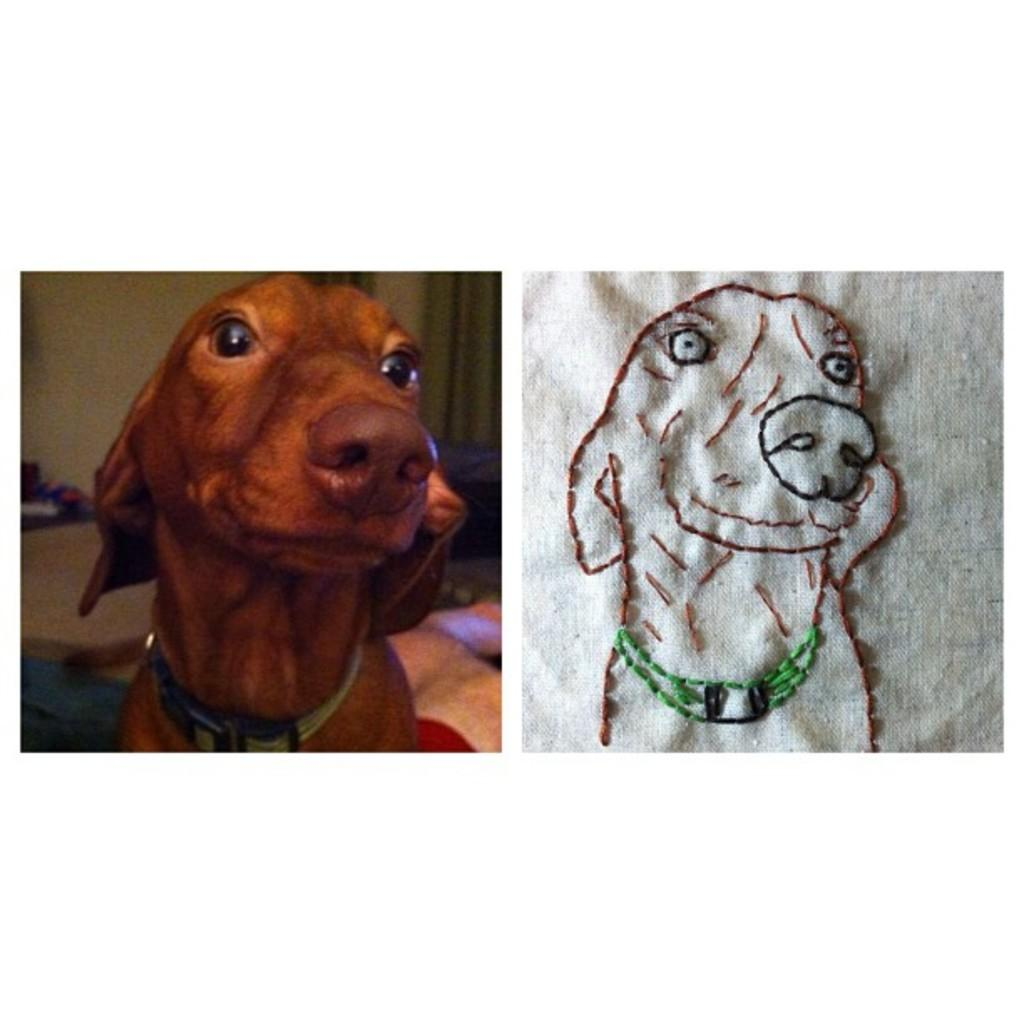What activity are the group of people engaged in? The group of people are playing football on a field. What can be seen at each end of the field? There is a goalpost at each end of the field. How many wings can be seen on the football in the image? There are no wings on the football in the image, as footballs do not have wings. 